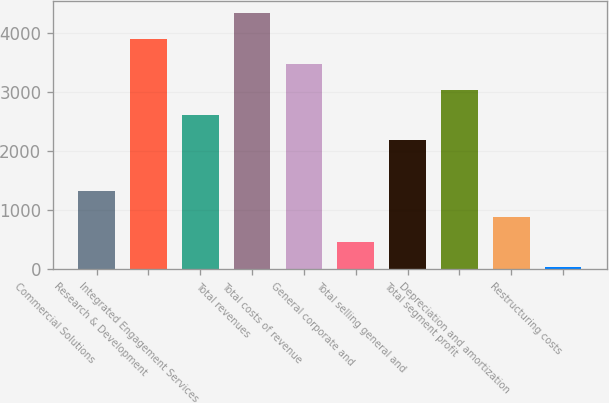Convert chart to OTSL. <chart><loc_0><loc_0><loc_500><loc_500><bar_chart><fcel>Commercial Solutions<fcel>Research & Development<fcel>Integrated Engagement Services<fcel>Total revenues<fcel>Total costs of revenue<fcel>General corporate and<fcel>Total selling general and<fcel>Total segment profit<fcel>Depreciation and amortization<fcel>Restructuring costs<nl><fcel>1318.8<fcel>3896.4<fcel>2607.6<fcel>4326<fcel>3466.8<fcel>459.6<fcel>2178<fcel>3037.2<fcel>889.2<fcel>30<nl></chart> 